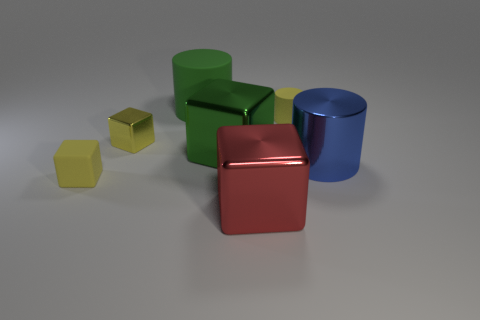There is a green metal object that is the same size as the red shiny cube; what is its shape? The green metal object has the same cubic shape as the red shiny cube. They both have six faces, twelve edges, and eight vertices, characteristic of a cube. 